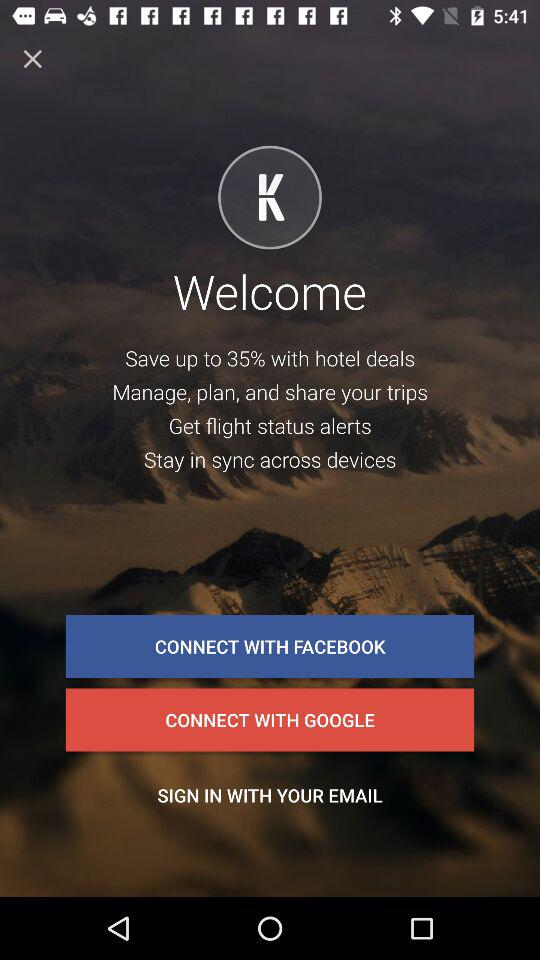Which application can the user sign in with? The user can sign in with "FACEBOOK" and "GOOGLE". 